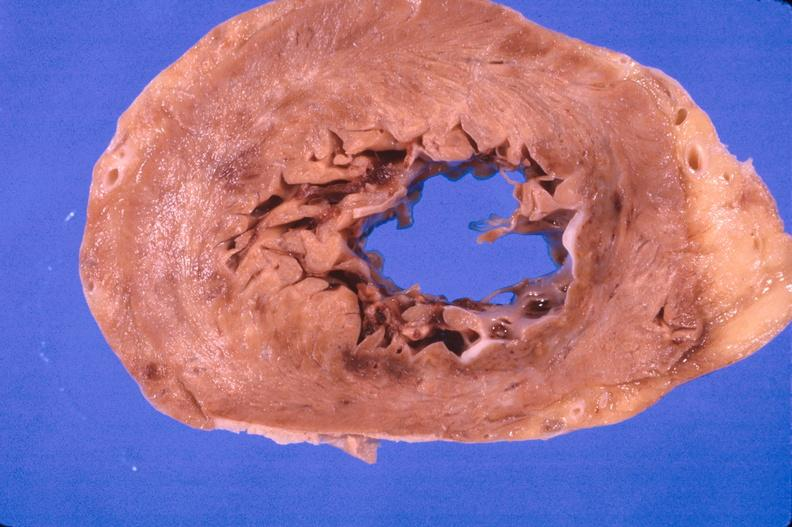does this image show heart, myocardial infarction free wall, 6 days old, in a patient with diabetes mellitus and hypertension?
Answer the question using a single word or phrase. Yes 